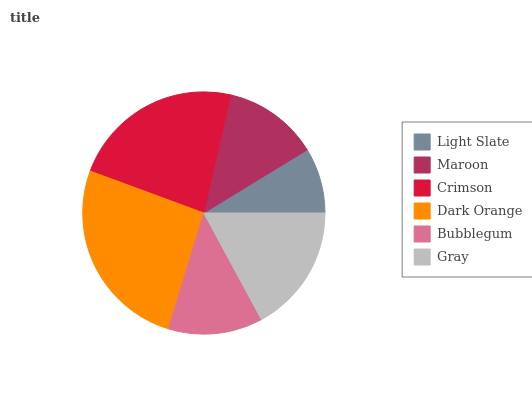Is Light Slate the minimum?
Answer yes or no. Yes. Is Dark Orange the maximum?
Answer yes or no. Yes. Is Maroon the minimum?
Answer yes or no. No. Is Maroon the maximum?
Answer yes or no. No. Is Maroon greater than Light Slate?
Answer yes or no. Yes. Is Light Slate less than Maroon?
Answer yes or no. Yes. Is Light Slate greater than Maroon?
Answer yes or no. No. Is Maroon less than Light Slate?
Answer yes or no. No. Is Gray the high median?
Answer yes or no. Yes. Is Maroon the low median?
Answer yes or no. Yes. Is Bubblegum the high median?
Answer yes or no. No. Is Crimson the low median?
Answer yes or no. No. 